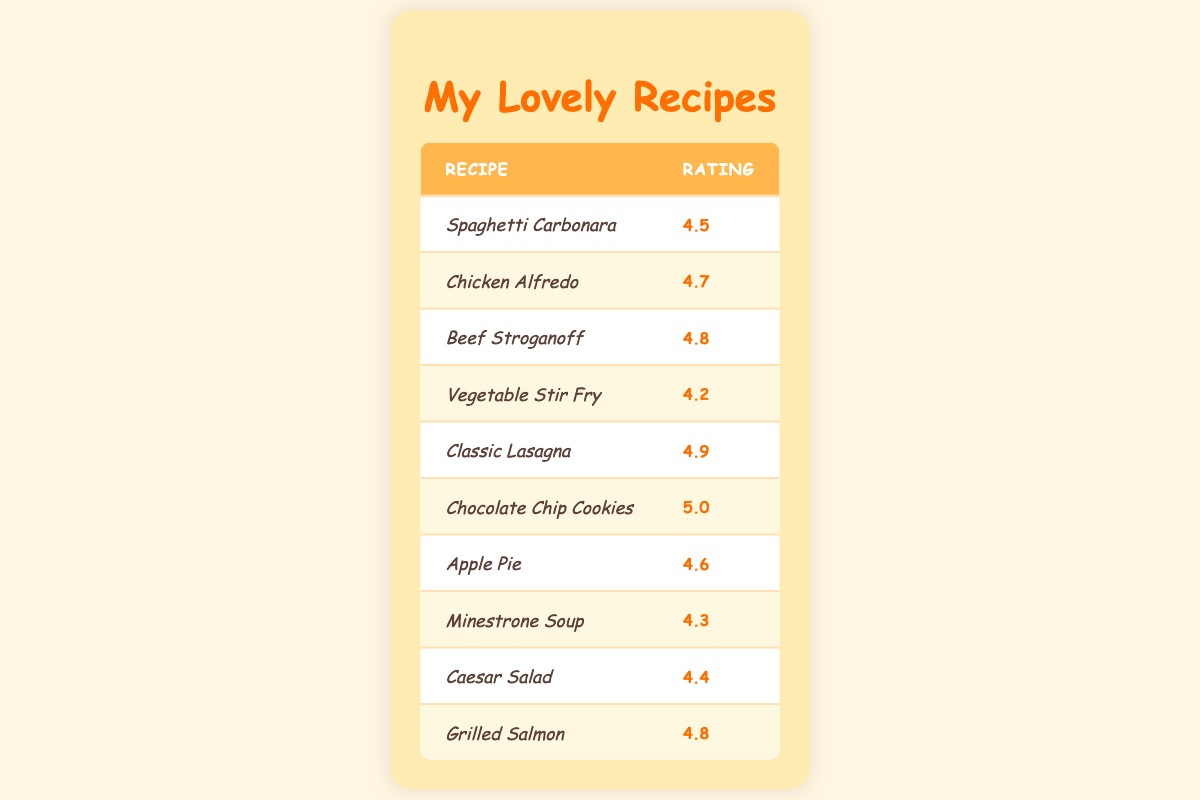What is the highest-rated recipe? The highest rating in the table is 5.0, which belongs to "Chocolate Chip Cookies".
Answer: Chocolate Chip Cookies Which recipe has a rating of 4.7? By looking at the table, "Chicken Alfredo" has a rating of 4.7.
Answer: Chicken Alfredo How many recipes have a rating greater than 4.5? The recipes with ratings greater than 4.5 are: Chicken Alfredo (4.7), Beef Stroganoff (4.8), Classic Lasagna (4.9), Chocolate Chip Cookies (5.0), Apple Pie (4.6), and Grilled Salmon (4.8). This totals to 6 recipes.
Answer: 6 What is the average rating of the recipes listed? To find the average, sum all the ratings: 4.5 + 4.7 + 4.8 + 4.2 + 4.9 + 5.0 + 4.6 + 4.3 + 4.4 + 4.8 = 48.8. There are 10 recipes, so the average rating is 48.8 / 10 = 4.88.
Answer: 4.88 Which recipe has the lowest rating? The lowest rating in the table is 4.2, corresponding to the "Vegetable Stir Fry".
Answer: Vegetable Stir Fry Are there more recipes with ratings above 4.5 or ratings below 4.5? There are 6 recipes with ratings above 4.5 (Chicken Alfredo, Beef Stroganoff, Classic Lasagna, Chocolate Chip Cookies, Apple Pie, Grilled Salmon) and 4 recipes below or equal to 4.5 (Spaghetti Carbonara, Vegetable Stir Fry, Minestrone Soup, Caesar Salad). Since 6 is greater than 4, there are more recipes above 4.5.
Answer: More recipes above 4.5 How many recipes received a rating of 4.4 or higher? The recipes with ratings of 4.4 and above are: Spaghetti Carbonara (4.5), Chicken Alfredo (4.7), Beef Stroganoff (4.8), Classic Lasagna (4.9), Chocolate Chip Cookies (5.0), Apple Pie (4.6), Grilled Salmon (4.8), and Caesar Salad (4.4). This makes a total of 8 recipes.
Answer: 8 Is "Minestrone Soup" rated higher than "Caesar Salad"? "Minestrone Soup" has a rating of 4.3, while "Caesar Salad" is rated 4.4. Since 4.3 is less than 4.4, "Minestrone Soup" is not rated higher than "Caesar Salad".
Answer: No What is the difference in rating between the highest and lowest recipe? The highest-rated recipe is "Chocolate Chip Cookies" at 5.0 and the lowest is "Vegetable Stir Fry" at 4.2. The difference is 5.0 - 4.2 = 0.8.
Answer: 0.8 